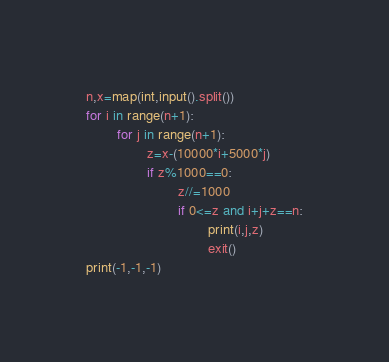Convert code to text. <code><loc_0><loc_0><loc_500><loc_500><_Python_>n,x=map(int,input().split())
for i in range(n+1):
        for j in range(n+1):
                z=x-(10000*i+5000*j)
                if z%1000==0:
                        z//=1000
                        if 0<=z and i+j+z==n:
                                print(i,j,z)
                                exit()
print(-1,-1,-1)</code> 